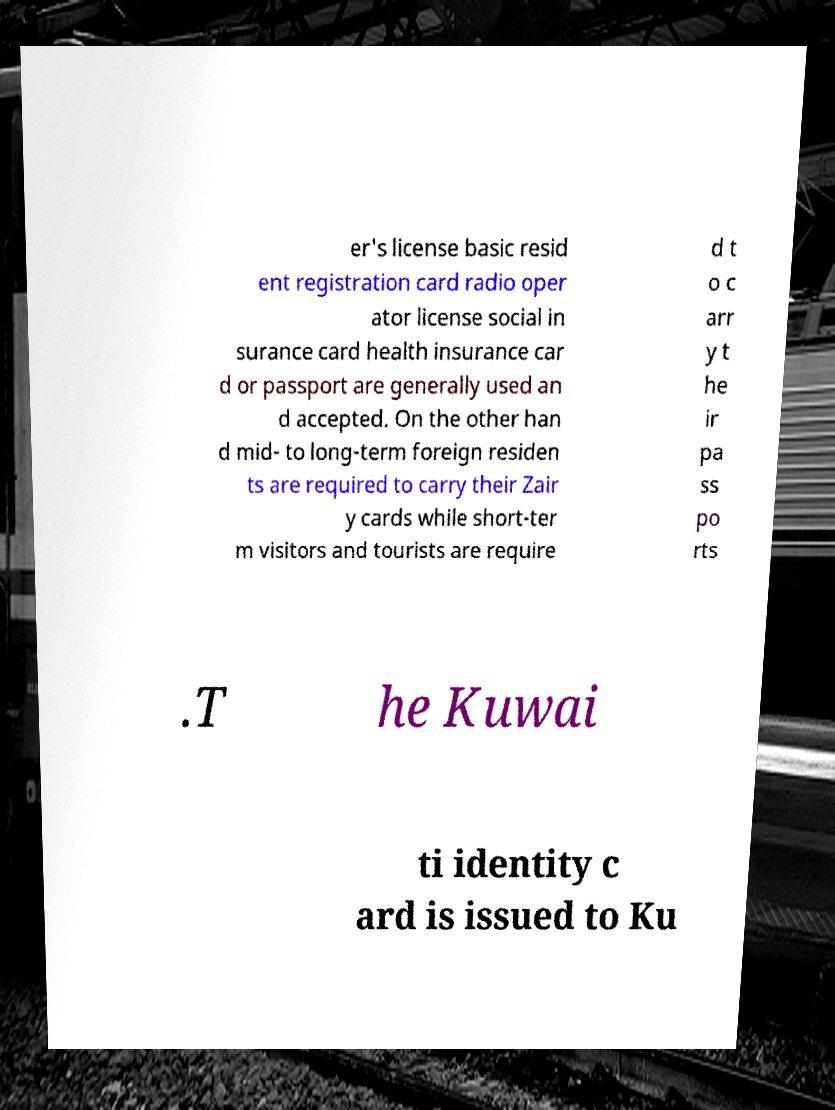What messages or text are displayed in this image? I need them in a readable, typed format. er's license basic resid ent registration card radio oper ator license social in surance card health insurance car d or passport are generally used an d accepted. On the other han d mid- to long-term foreign residen ts are required to carry their Zair y cards while short-ter m visitors and tourists are require d t o c arr y t he ir pa ss po rts .T he Kuwai ti identity c ard is issued to Ku 